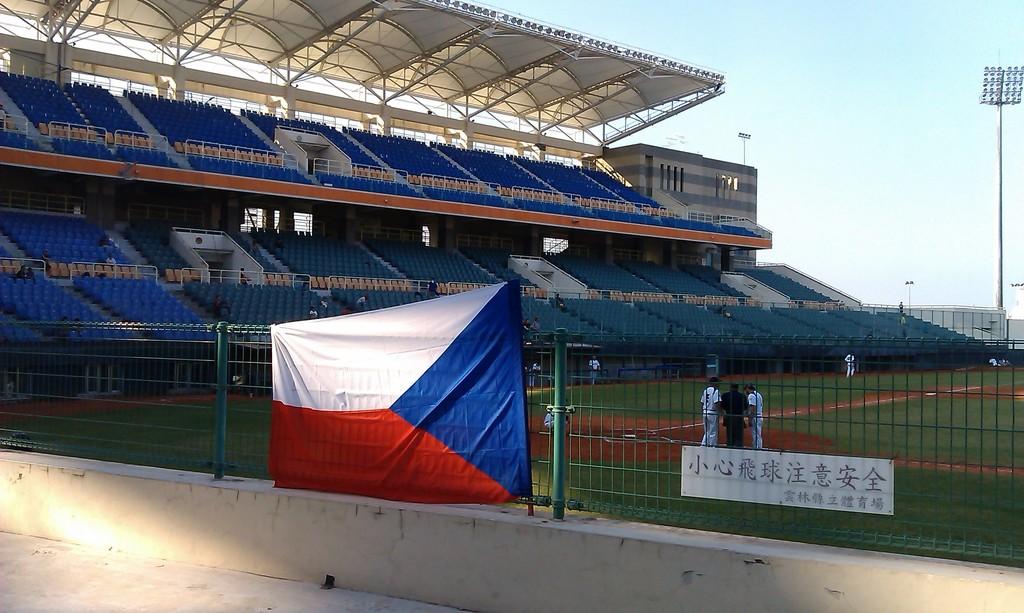Written in foreign language?
Your answer should be very brief. Yes. 